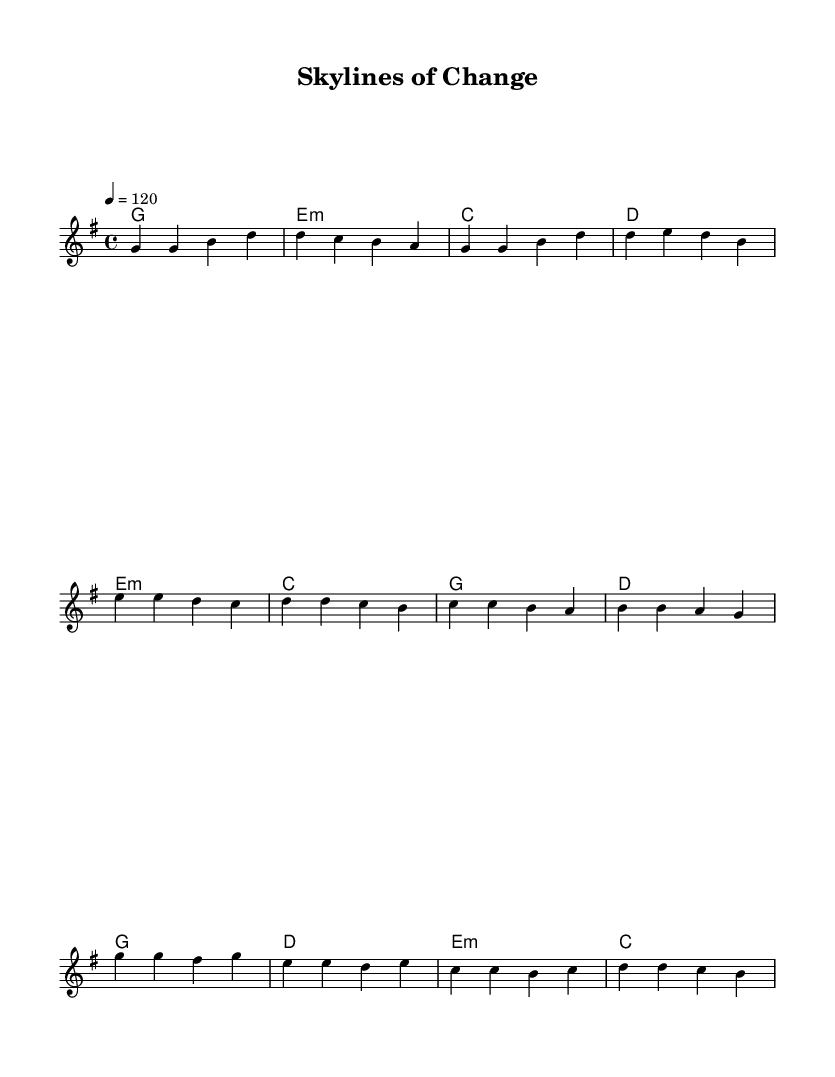What is the key signature of this music? The key signature is indicated at the beginning of the score, and it shows one sharp, which corresponds to G major.
Answer: G major What is the time signature of this music? The time signature is found at the beginning of the score, represented as 4 over 4, indicating four beats per measure.
Answer: 4/4 What is the tempo marking of this music? The tempo marking appears at the start and states "4 = 120," which indicates the beats per minute.
Answer: 120 How many verses are there in the lyrics? The lyrics section includes a verse, a pre-chorus, and a chorus; the verse lyrics consist of the first section provided.
Answer: 1 What is the first note of the melody? The first note appears at the beginning of the melody section and is a G.
Answer: G Which chords are played during the chorus? By examining the harmonies specified for the chorus, the chords noted are G, D, E minor, and C.
Answer: G, D, E minor, C What theme do the lyrics of the song generally convey? The lyrics address urban development and change, referencing old streets and skyscrapers, showcasing a theme of transformation in an urban context.
Answer: Urban development 